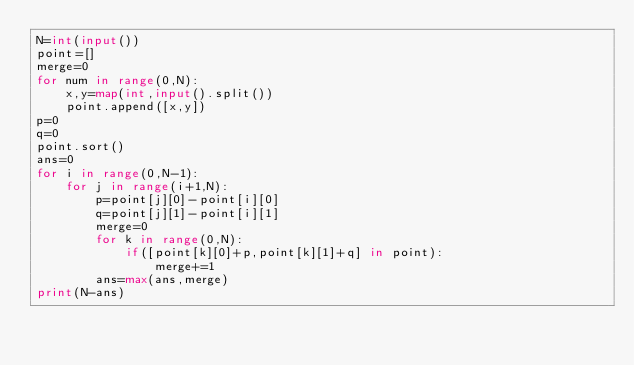Convert code to text. <code><loc_0><loc_0><loc_500><loc_500><_Python_>N=int(input())
point=[]
merge=0
for num in range(0,N):
    x,y=map(int,input().split())
    point.append([x,y])
p=0
q=0
point.sort()
ans=0
for i in range(0,N-1):
    for j in range(i+1,N):
        p=point[j][0]-point[i][0]
        q=point[j][1]-point[i][1]
        merge=0
        for k in range(0,N):
            if([point[k][0]+p,point[k][1]+q] in point):
                merge+=1
        ans=max(ans,merge)
print(N-ans)
</code> 